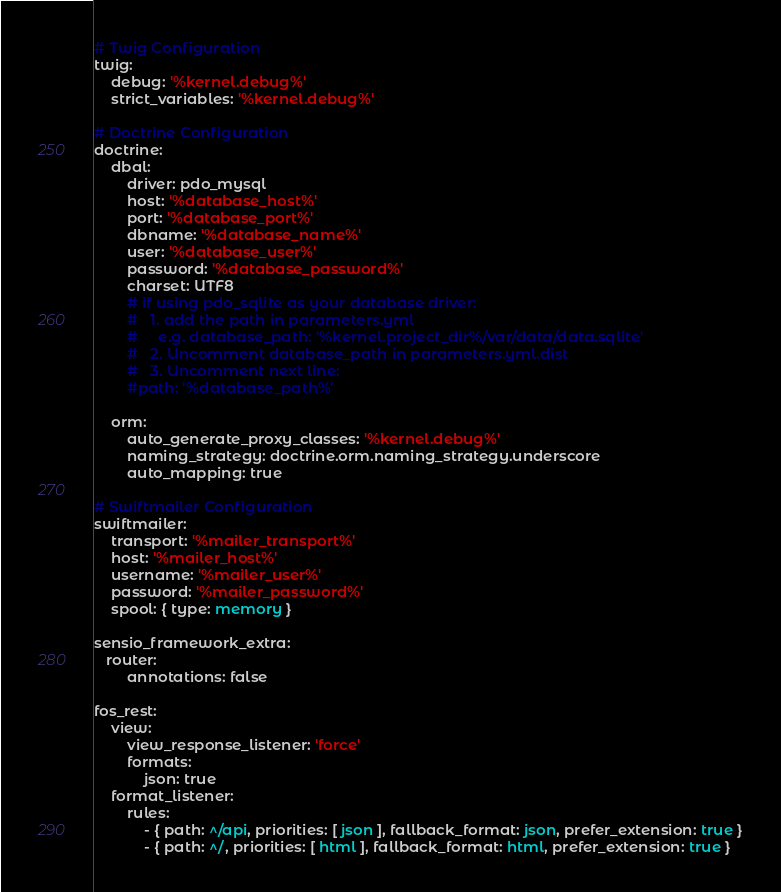<code> <loc_0><loc_0><loc_500><loc_500><_YAML_>
# Twig Configuration
twig:
    debug: '%kernel.debug%'
    strict_variables: '%kernel.debug%'

# Doctrine Configuration
doctrine:
    dbal:
        driver: pdo_mysql
        host: '%database_host%'
        port: '%database_port%'
        dbname: '%database_name%'
        user: '%database_user%'
        password: '%database_password%'
        charset: UTF8
        # if using pdo_sqlite as your database driver:
        #   1. add the path in parameters.yml
        #     e.g. database_path: '%kernel.project_dir%/var/data/data.sqlite'
        #   2. Uncomment database_path in parameters.yml.dist
        #   3. Uncomment next line:
        #path: '%database_path%'

    orm:
        auto_generate_proxy_classes: '%kernel.debug%'
        naming_strategy: doctrine.orm.naming_strategy.underscore
        auto_mapping: true

# Swiftmailer Configuration
swiftmailer:
    transport: '%mailer_transport%'
    host: '%mailer_host%'
    username: '%mailer_user%'
    password: '%mailer_password%'
    spool: { type: memory }

sensio_framework_extra:
   router:
        annotations: false

fos_rest:
    view:
        view_response_listener: 'force'
        formats:
            json: true
    format_listener:
        rules:
            - { path: ^/api, priorities: [ json ], fallback_format: json, prefer_extension: true }
            - { path: ^/, priorities: [ html ], fallback_format: html, prefer_extension: true }
</code> 